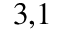Convert formula to latex. <formula><loc_0><loc_0><loc_500><loc_500>^ { 3 , 1 }</formula> 